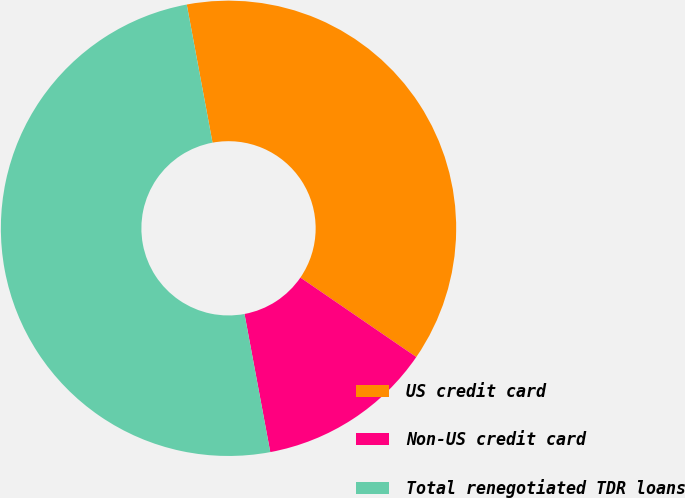<chart> <loc_0><loc_0><loc_500><loc_500><pie_chart><fcel>US credit card<fcel>Non-US credit card<fcel>Total renegotiated TDR loans<nl><fcel>37.5%<fcel>12.5%<fcel>50.0%<nl></chart> 